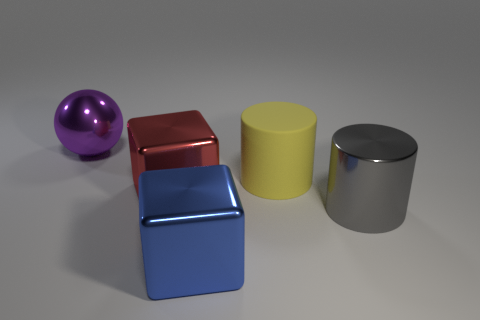How would the size of these objects compare to everyday items? The purple sphere might be the size of a small melon, the red cube roughly the height of a large coffee mug, the yellow cylinder about as tall as a soup can, and the silver cylinder similar in size to a small paint can. 